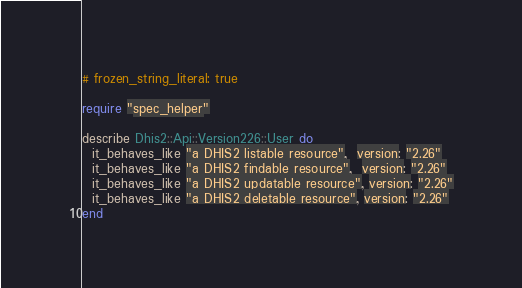<code> <loc_0><loc_0><loc_500><loc_500><_Ruby_># frozen_string_literal: true

require "spec_helper"

describe Dhis2::Api::Version226::User do
  it_behaves_like "a DHIS2 listable resource",  version: "2.26"
  it_behaves_like "a DHIS2 findable resource",  version: "2.26"
  it_behaves_like "a DHIS2 updatable resource", version: "2.26"
  it_behaves_like "a DHIS2 deletable resource", version: "2.26"
end
</code> 